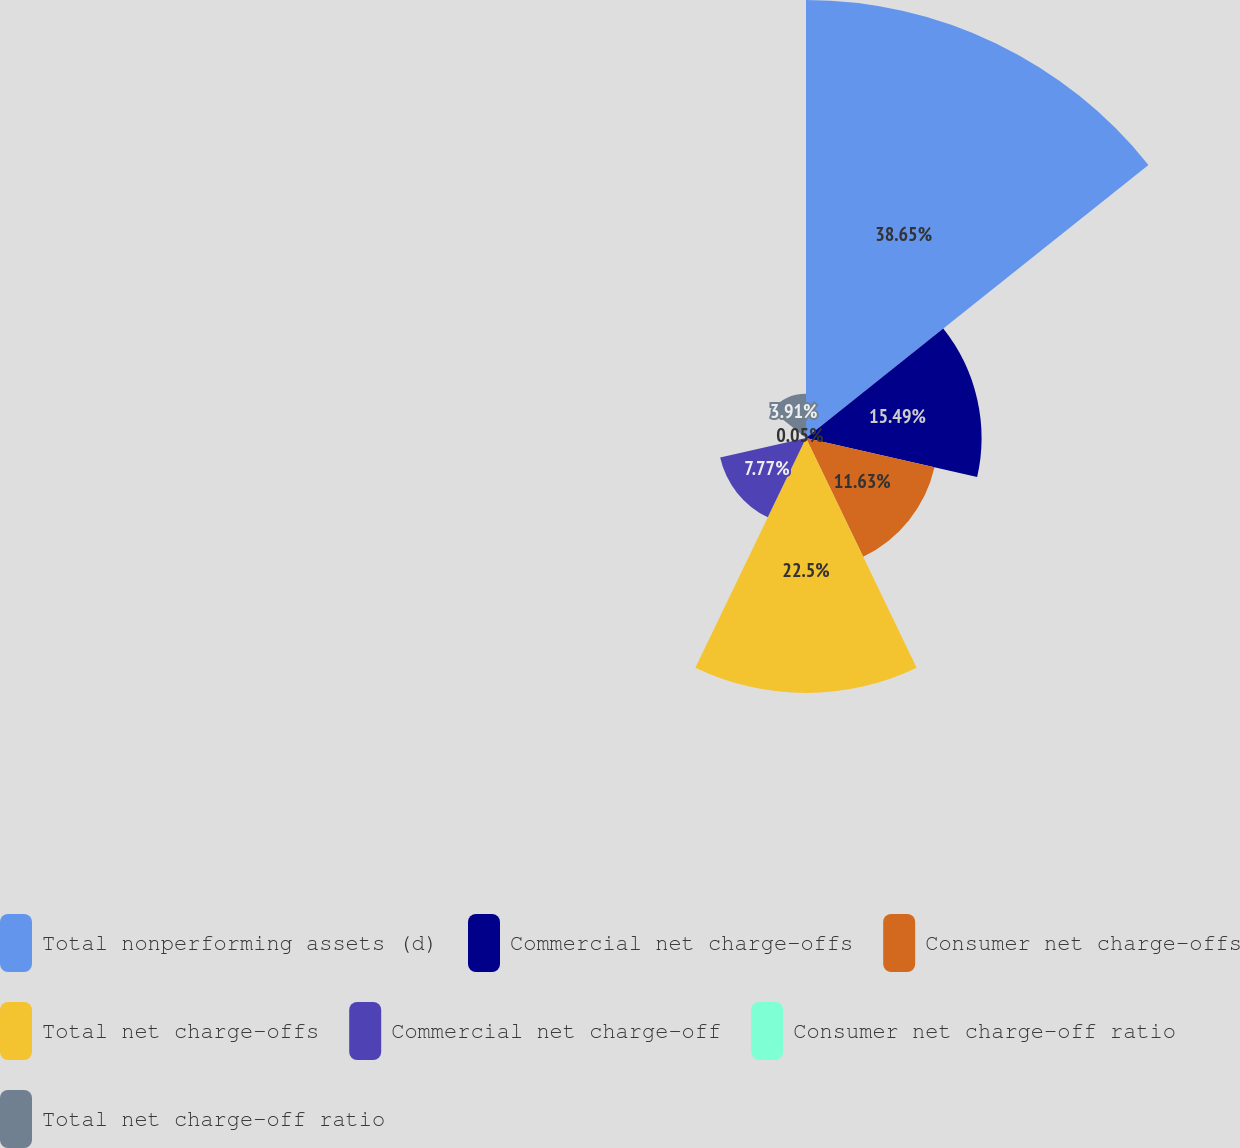Convert chart to OTSL. <chart><loc_0><loc_0><loc_500><loc_500><pie_chart><fcel>Total nonperforming assets (d)<fcel>Commercial net charge-offs<fcel>Consumer net charge-offs<fcel>Total net charge-offs<fcel>Commercial net charge-off<fcel>Consumer net charge-off ratio<fcel>Total net charge-off ratio<nl><fcel>38.65%<fcel>15.49%<fcel>11.63%<fcel>22.5%<fcel>7.77%<fcel>0.05%<fcel>3.91%<nl></chart> 